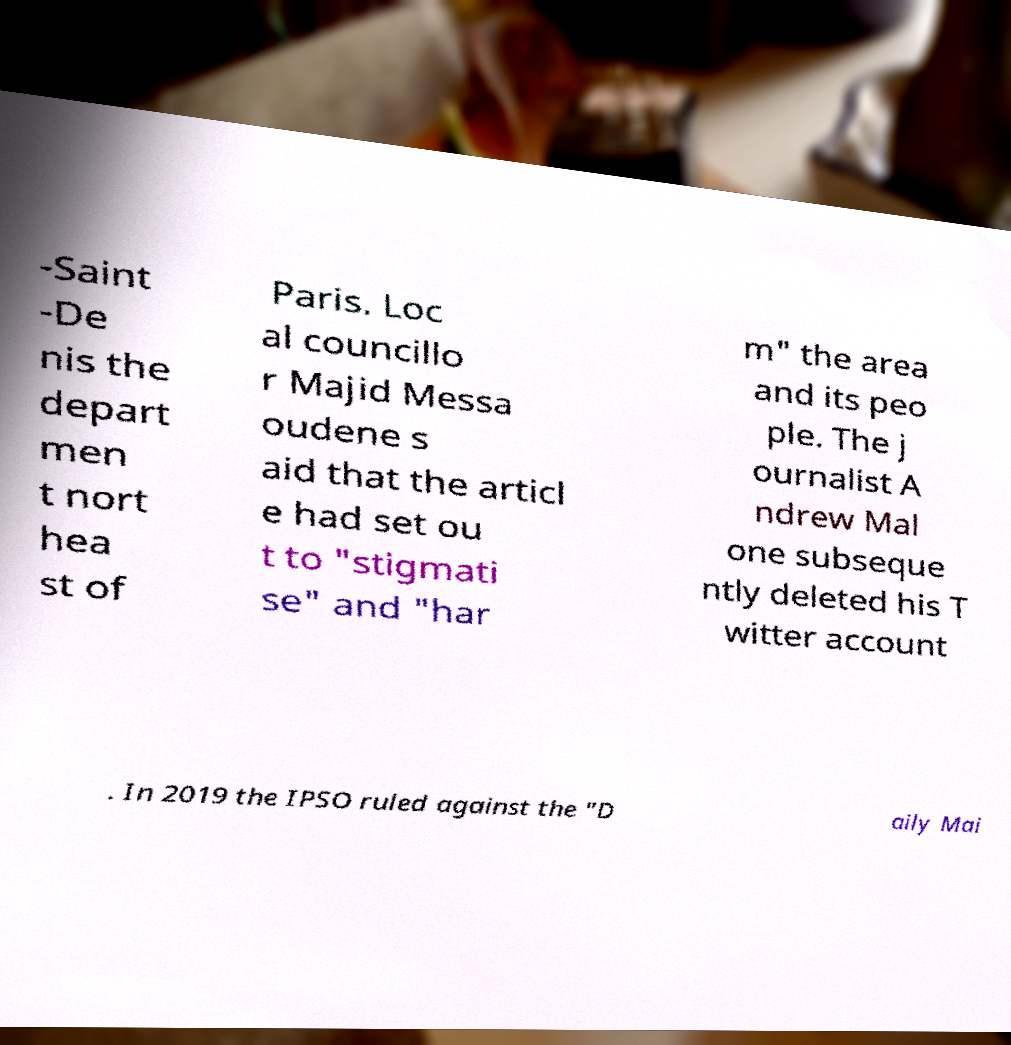For documentation purposes, I need the text within this image transcribed. Could you provide that? -Saint -De nis the depart men t nort hea st of Paris. Loc al councillo r Majid Messa oudene s aid that the articl e had set ou t to "stigmati se" and "har m" the area and its peo ple. The j ournalist A ndrew Mal one subseque ntly deleted his T witter account . In 2019 the IPSO ruled against the "D aily Mai 